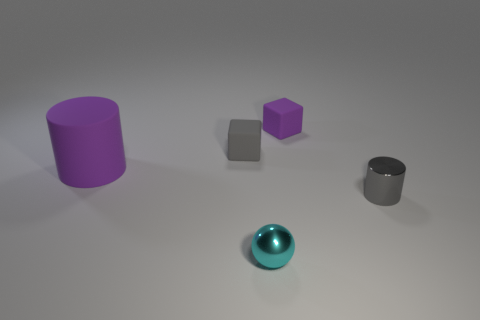What time of day does the lighting suggest in this image? The lighting in the image doesn't clearly suggest a time of day, as it is artificial and studio-like with no natural light cues such as sunlight or a sky to provide that context. The even and diffuse lighting suggests an indoor, controlled environment. 